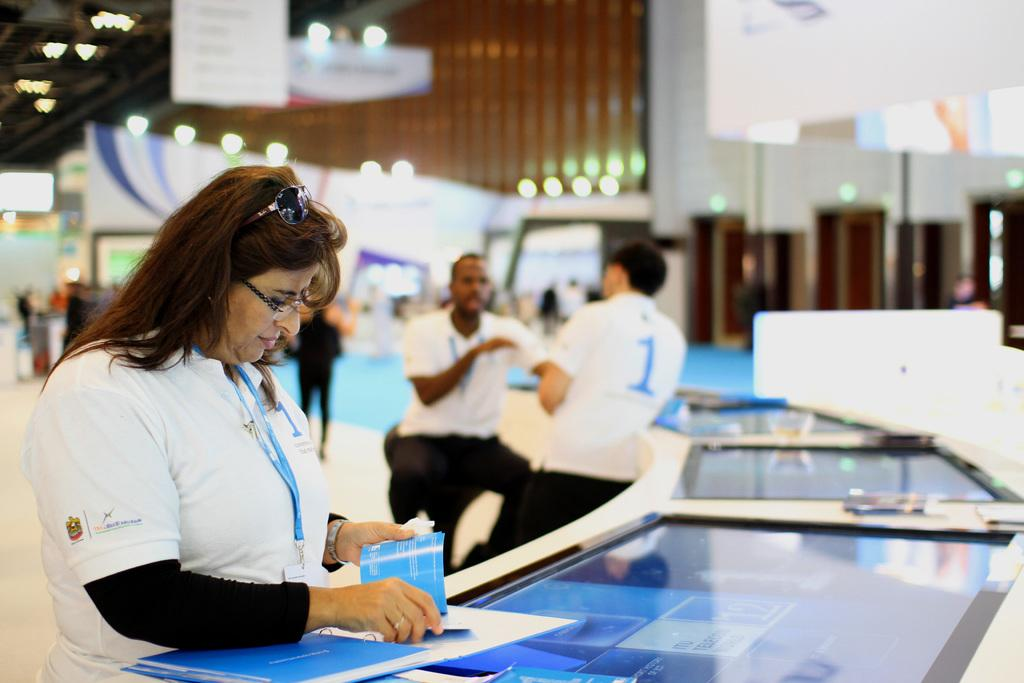Who or what is present in the image? There are people in the image. What is on the table in the image? There is a table with objects in the image. What can be seen illuminating the scene in the image? There are lights visible in the image. What architectural features are present in the image? There are pillars in the image. What type of structure is depicted in the image? There is a wall in the image. How many ants can be seen crawling on the wall in the image? There are no ants present in the image; it only features people, a table, lights, pillars, and a wall. What type of curtain is hanging from the pillars in the image? There is no curtain present in the image; only pillars and a wall are visible. 